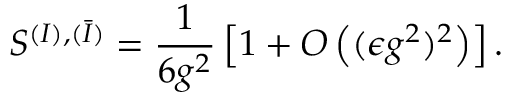Convert formula to latex. <formula><loc_0><loc_0><loc_500><loc_500>S ^ { ( I ) , ( \bar { I } ) } = \frac { 1 } { 6 g ^ { 2 } } \left [ 1 + O \left ( ( \epsilon g ^ { 2 } ) ^ { 2 } \right ) \right ] .</formula> 